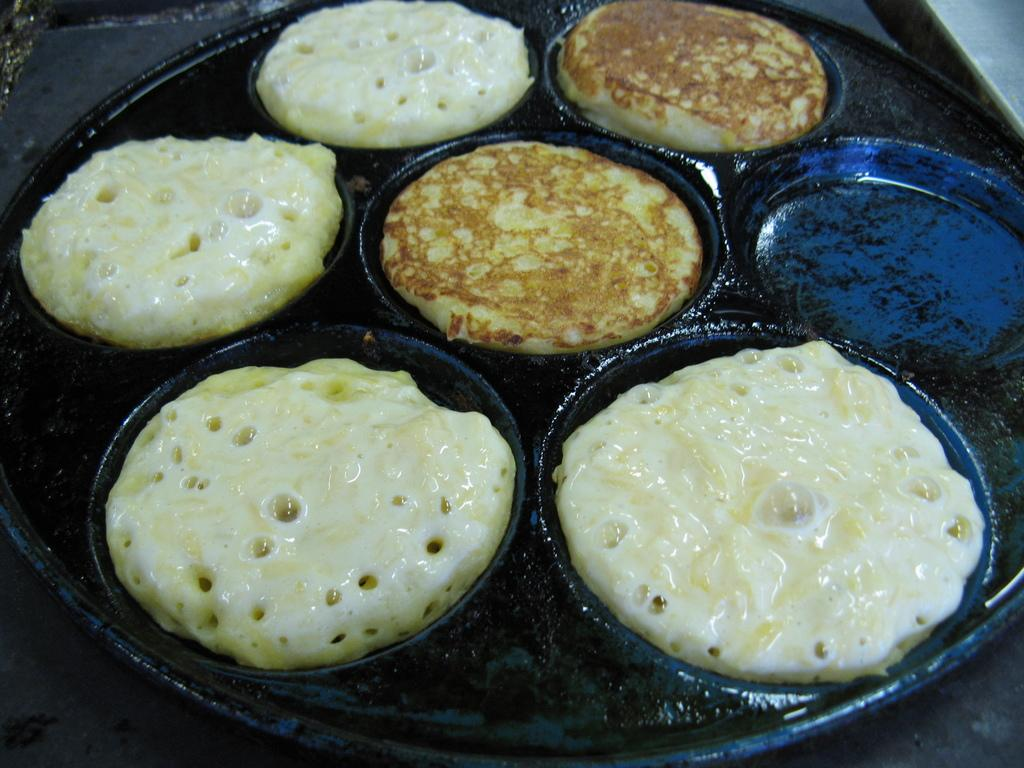What is happening in the image? Food is being prepared in the image. What surface is the food being prepared on? The food is being prepared on a metal plate. How many legs does the food have in the image? The food does not have legs, as it is an inanimate object. 